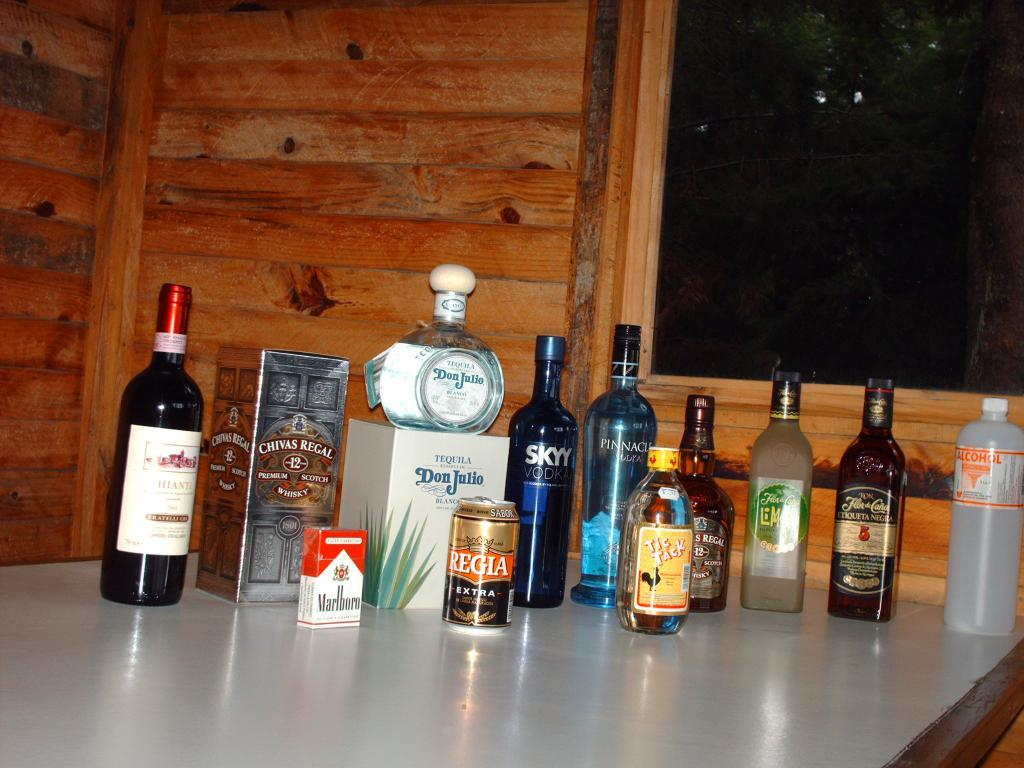<image>
Summarize the visual content of the image. Bottles of alcohol and a box of Marlboro cigarettes on a table. 